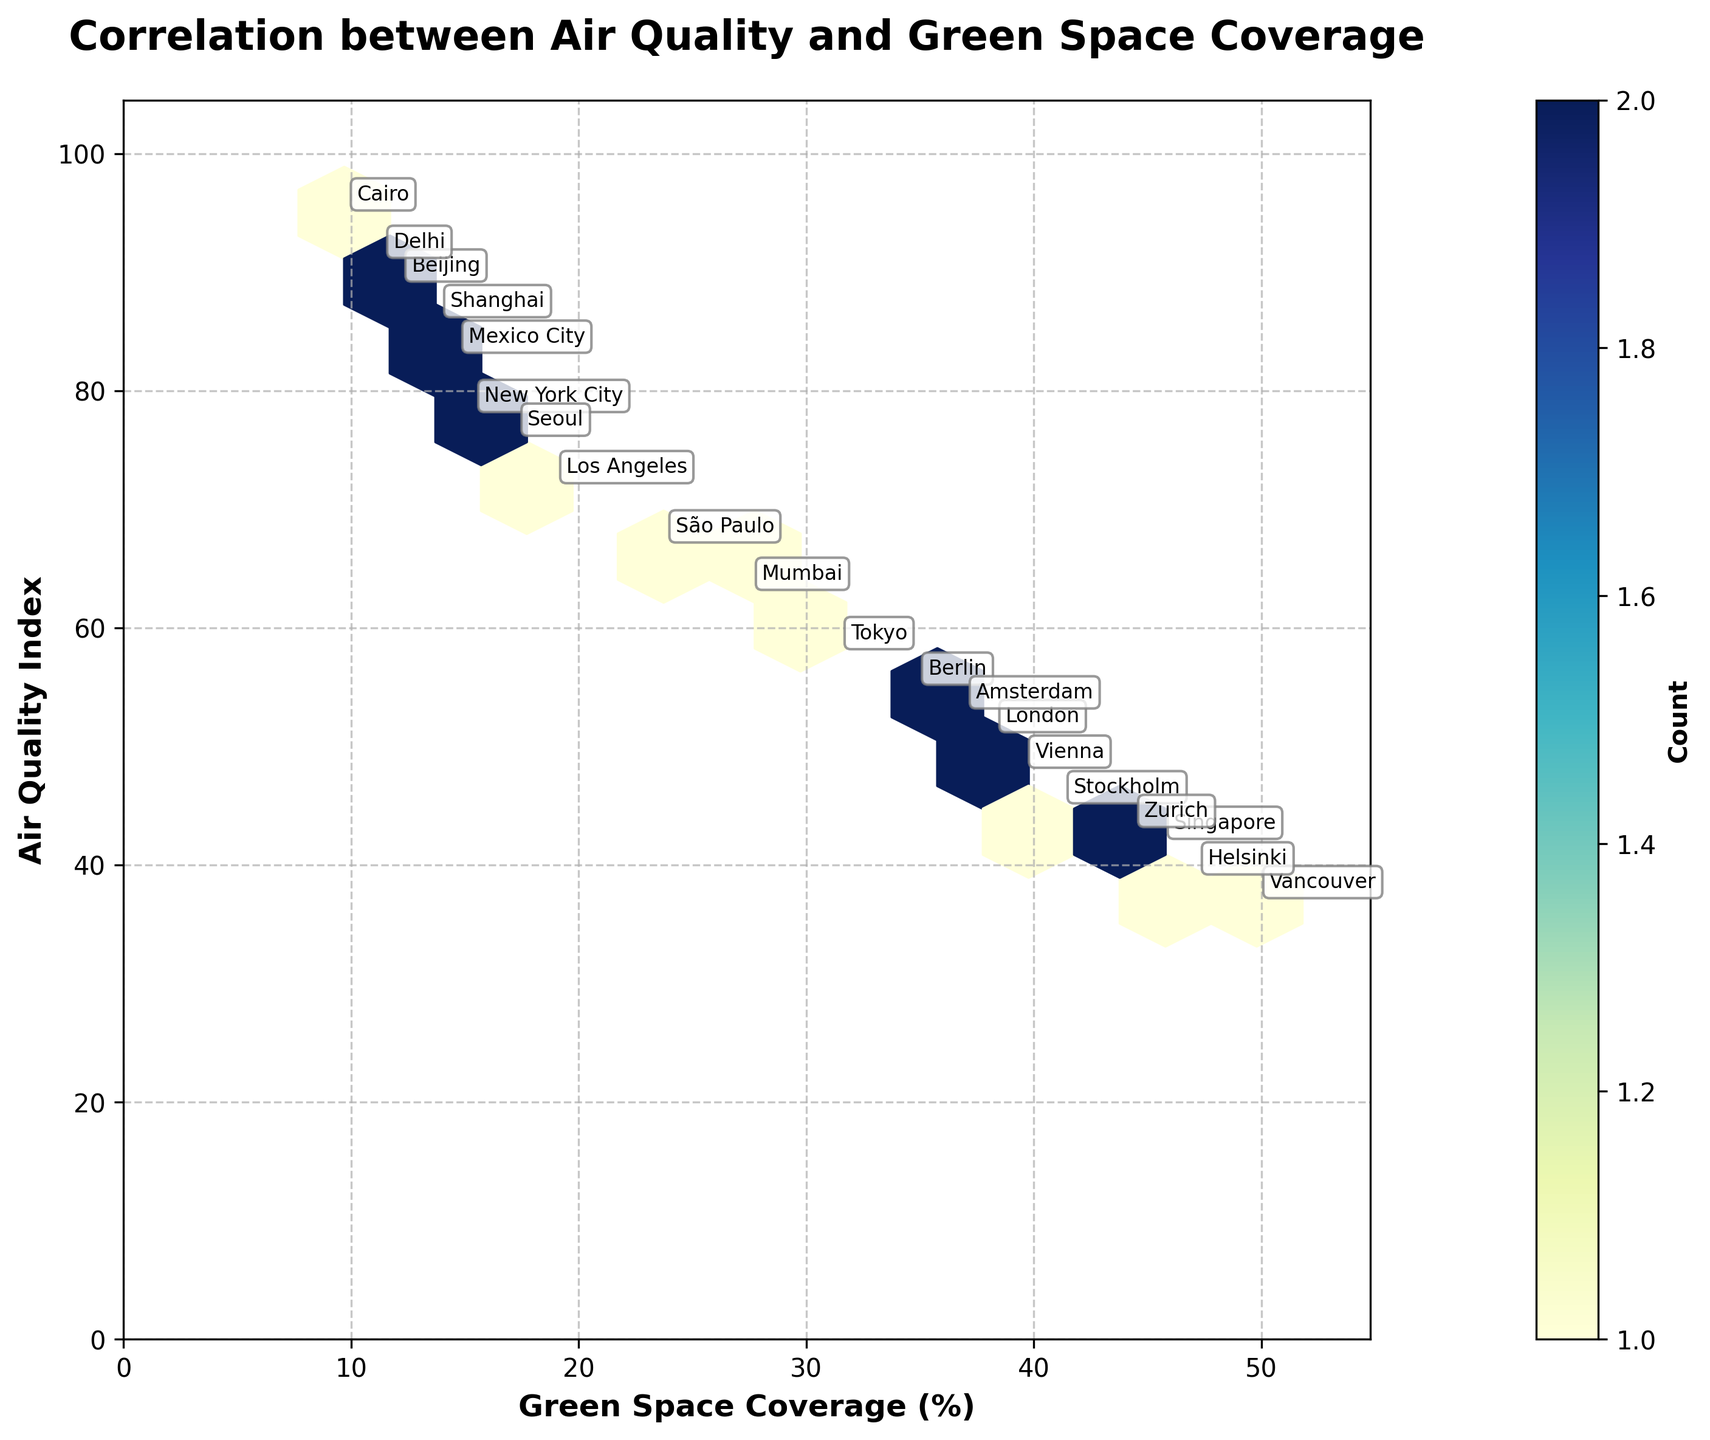What is the title of the plot? The title is written at the top of the plot and is typically in a larger and bold font. In this case, it reads "Correlation between Air Quality and Green Space Coverage."
Answer: Correlation between Air Quality and Green Space Coverage What does the color intensity represent in the hexbin plot? The color intensity in a hexbin plot represents the count of data points in each hexagonal bin. Darker or more intense colors indicate higher concentrations of data points.
Answer: Count of data points What is the minimum and maximum value for Green Space Coverage (%) shown in the plot? The x-axis represents the Green Space Coverage (%). According to the plot, the minimum value is near 0%, and the maximum value is around 55%, as indicated by the axis limits.
Answer: 0%, 55% Which city has the lowest Air Quality Index (AQI) and what is its Green Space Coverage (%)? By looking at the annotations on the plot, Vancouver has the lowest AQI at 37 and its Green Space Coverage is 49.8%.
Answer: Vancouver, 49.8% Is there a general trend between the Air Quality Index and Green Space Coverage? Examining the plot as a whole, a general trend can be observed where cities with higher Green Space Coverage tend to have a lower AQI, indicating a negative correlation.
Answer: Negative correlation What are the axis labels in the plot? The axis labels can be found on the axes. The x-axis is labeled "Green Space Coverage (%)" and the y-axis is labeled "Air Quality Index."
Answer: Green Space Coverage (%), Air Quality Index Which city has the highest Air Quality Index and what is its Green Space Coverage (%)? By looking at the annotations on the plot, Cairo has the highest AQI at 95 and its Green Space Coverage is 9.7%.
Answer: Cairo, 9.7% What is the range of Air Quality Index values in the plot? The y-axis shows the range of Air Quality Index values. The lowest value is around 0, and the highest value is about 100 as indicated by the axis limits.
Answer: 0, 100 Is there a noticeable cluster of cities with high Green Space Coverage and low Air Quality Index? Observing the plot, there seems to be a noticeable cluster of cities toward the upper middle left part of the plot where Green Space Coverage is high, and Air Quality Index is low.
Answer: Yes Based on the colorbar, what does the value at the darkest shade represent? The colorbar indicates the count of data points per bin; the darkest shade likely represents the highest count value on the colorbar scale, which is typically labeled next to the darkest shade on the bar.
Answer: Highest count value 